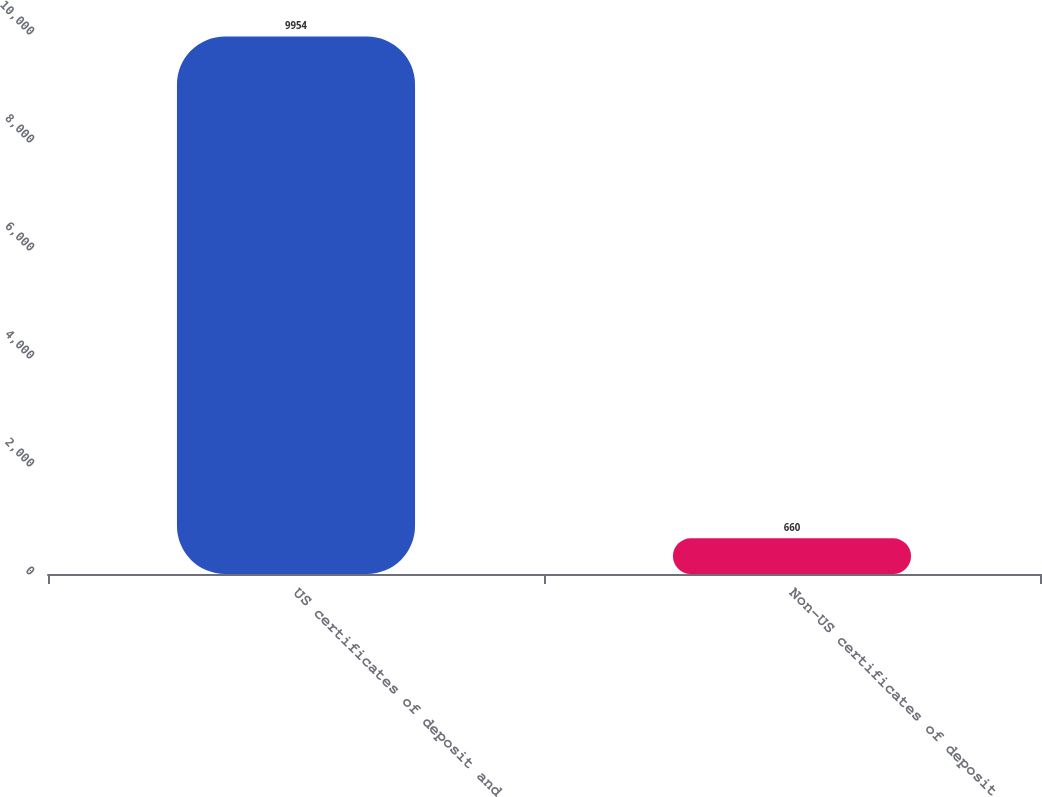Convert chart to OTSL. <chart><loc_0><loc_0><loc_500><loc_500><bar_chart><fcel>US certificates of deposit and<fcel>Non-US certificates of deposit<nl><fcel>9954<fcel>660<nl></chart> 